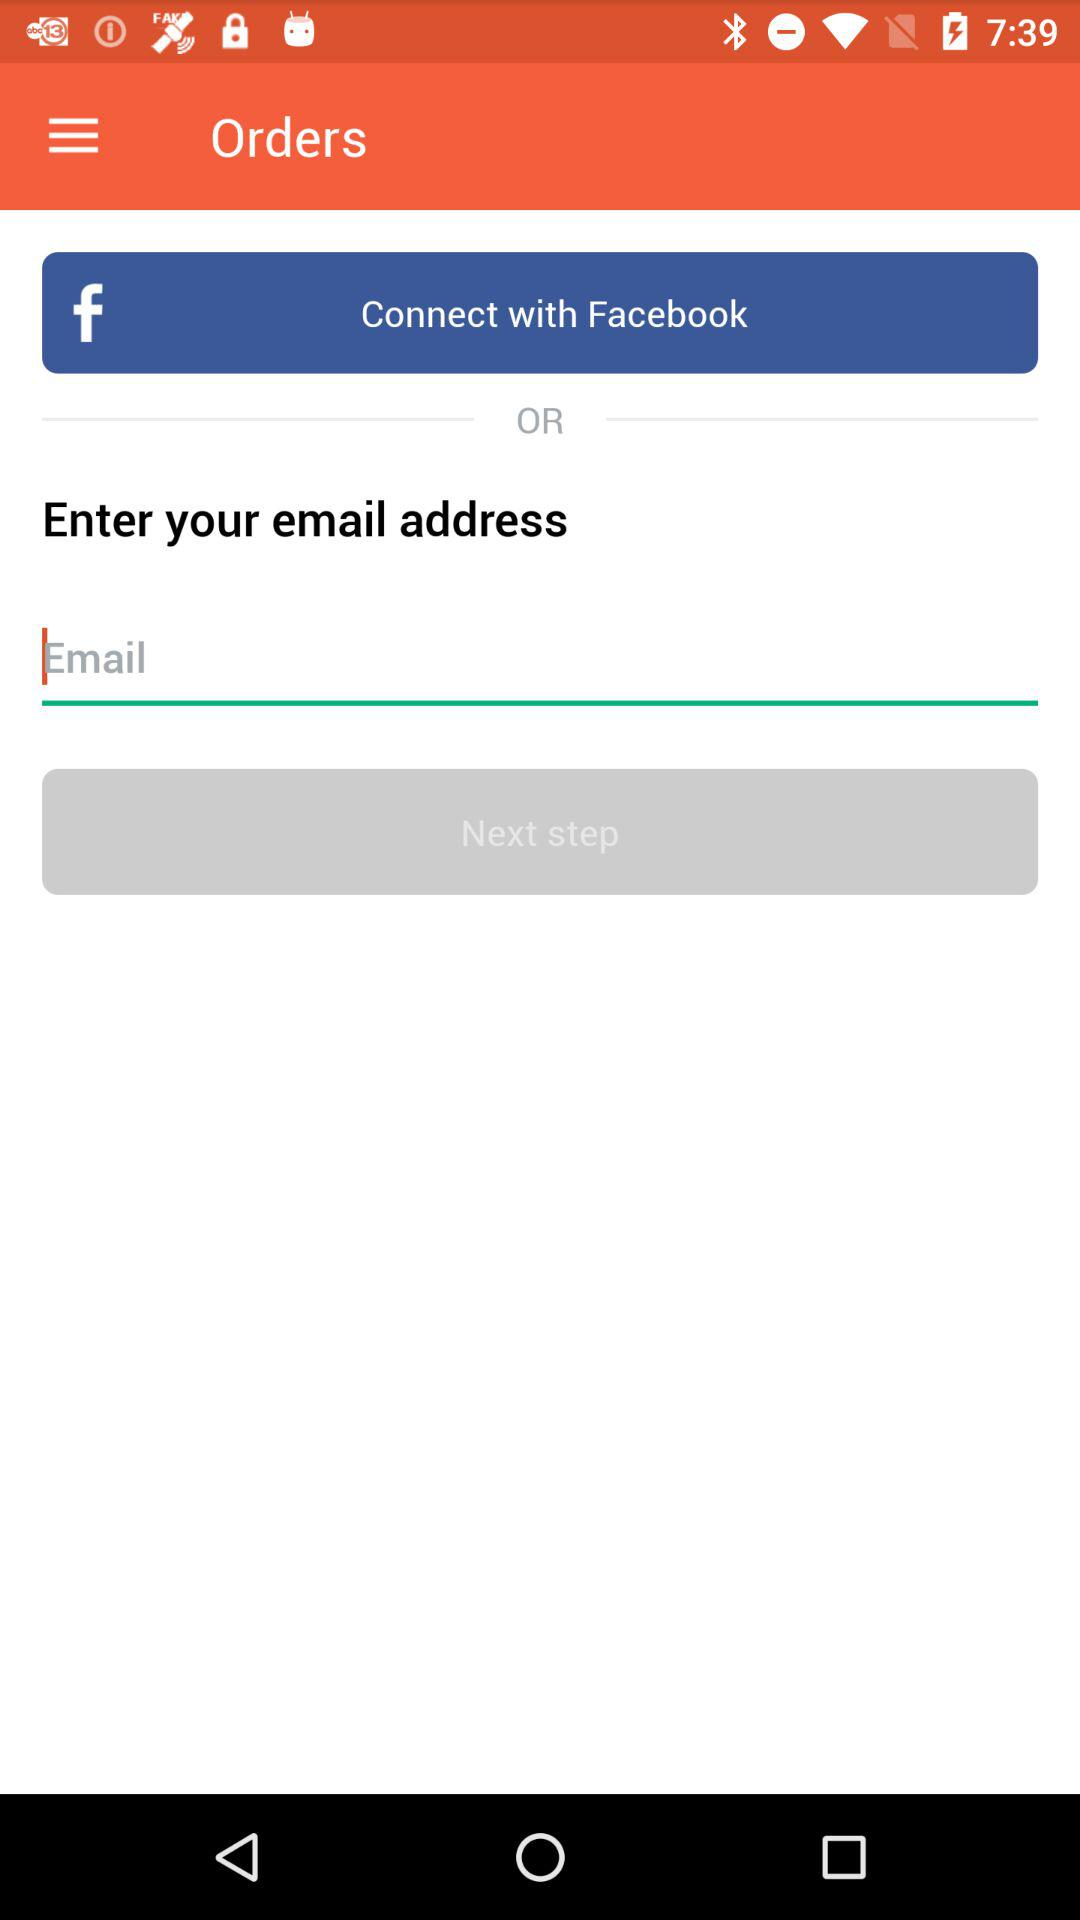Through what medium can I connect? You can connect with Facebook. 